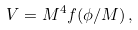Convert formula to latex. <formula><loc_0><loc_0><loc_500><loc_500>V = M ^ { 4 } f ( \phi / M ) \, ,</formula> 